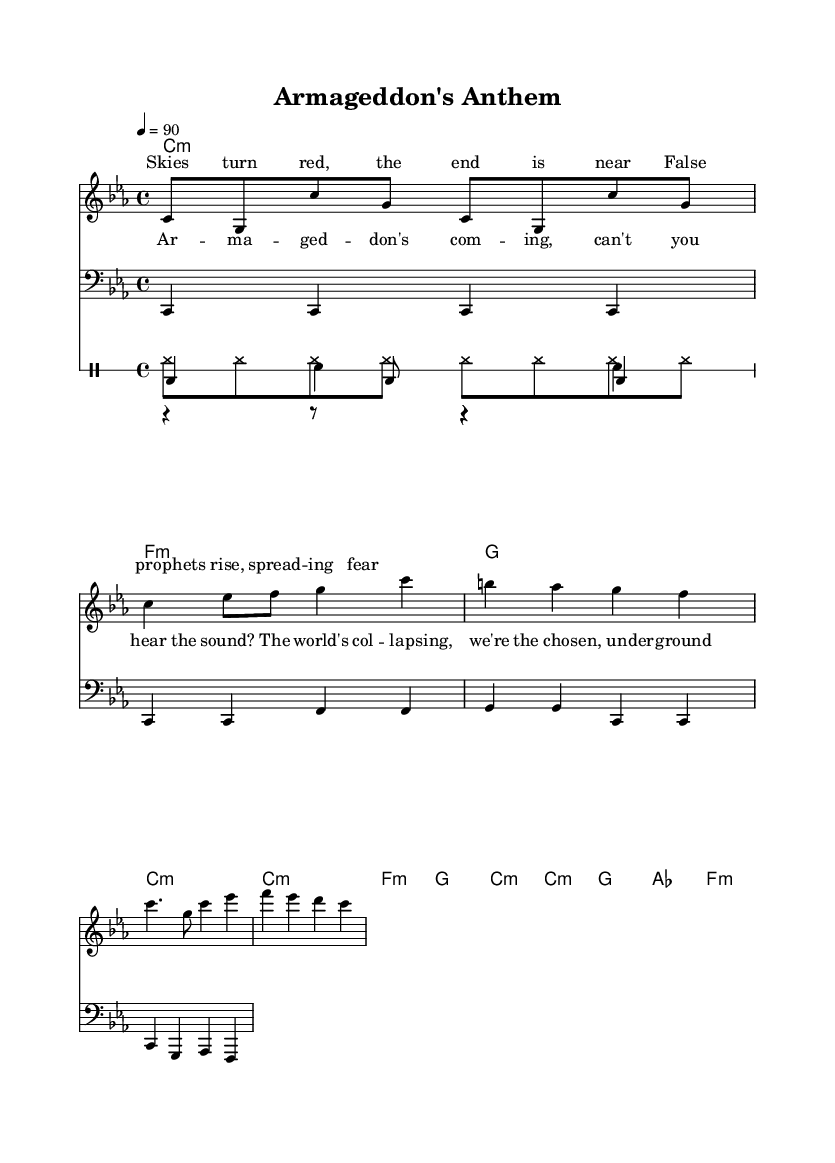What is the key signature of this music? The key signature is C minor, which is indicated by three flats in the key signature line.
Answer: C minor What is the time signature of the piece? The time signature is 4/4, shown at the beginning of the staff, indicating four beats per measure.
Answer: 4/4 What is the tempo marking for this piece? The tempo is marked as 4 = 90, meaning the quarter note gets 90 beats per minute.
Answer: 90 How many measures are in the chorus? The chorus consists of four measures, which can be counted by looking at the notation where the chorus lyrics are aligned.
Answer: 4 What type of musical intervals can be found in the melody? The melody primarily uses thirds and fifths, which can be identified by the distance between the notes within the scale.
Answer: Thirds and fifths What is the primary theme reflected in the lyrics? The primary theme reflected in the lyrics deals with apocalyptic imagery and fear of the end of days, evident from phrases like "the end is near."
Answer: Apocalyptic imagery How does the drum part contribute to the overall feel of the music? The drum part includes a kick, snare, and hi-hat pattern that supports the hip-hop rhythm, emphasizing the beat and contributing to the intensity of the apocalyptic theme.
Answer: Hip-hop rhythm 